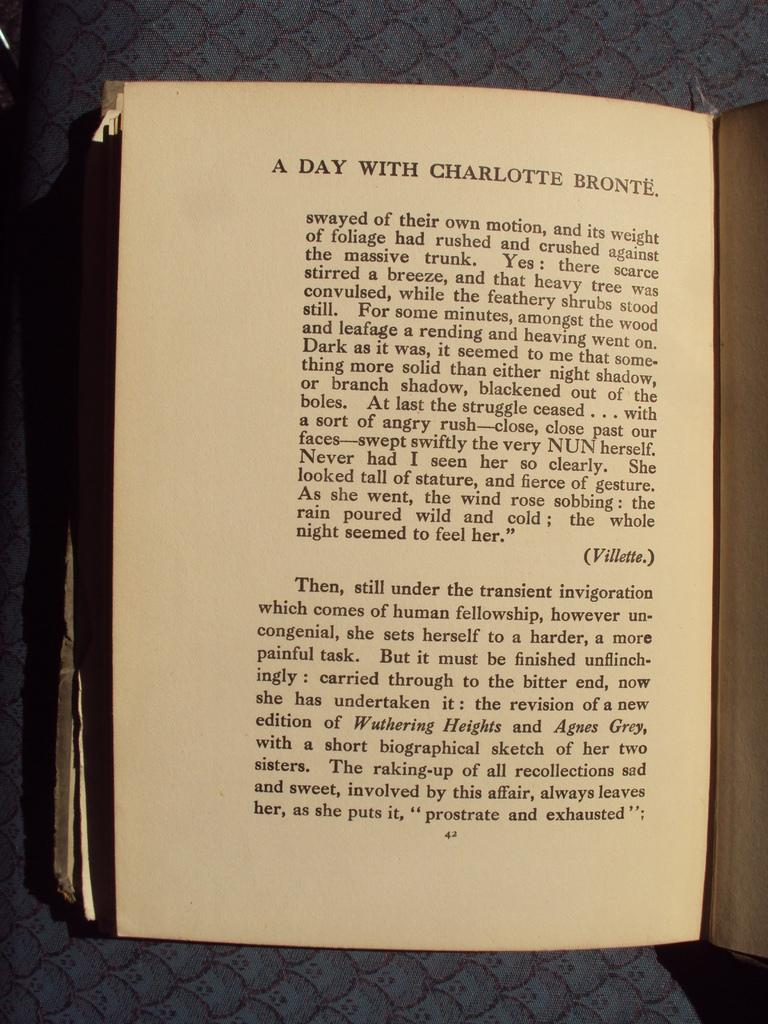<image>
Present a compact description of the photo's key features. the 42 page of A day with Charlotte Bronte  book is displayed 